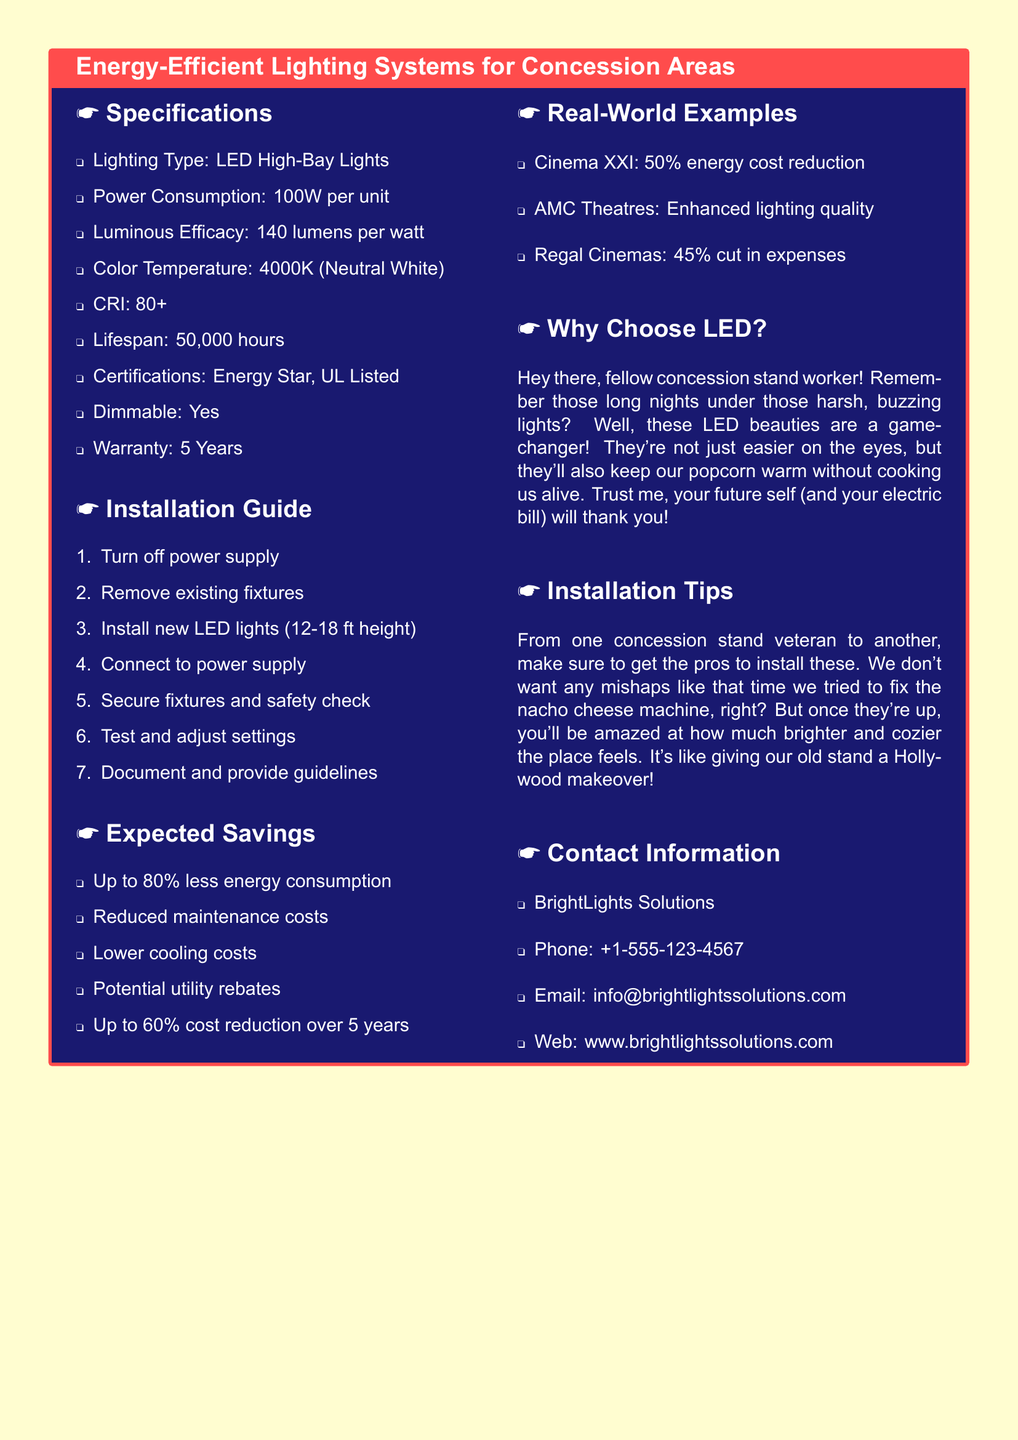What is the power consumption per unit? The power consumption is specifically stated in the specifications section of the document as 100W per unit.
Answer: 100W What type of lighting is used? The document specifies that LED High-Bay Lights are used in the concession areas.
Answer: LED High-Bay Lights What is the lifespan of the lighting system? The lifespan is indicated under specifications and is listed as 50,000 hours.
Answer: 50,000 hours What is the expected percentage of energy consumption reduction? The expected savings section states up to 80% less energy consumption.
Answer: 80% How long is the warranty for the lighting system? The warranty duration is mentioned in the specifications as 5 years.
Answer: 5 years What is one benefit of using LED lighting noted in the document? The document highlights reduced maintenance costs as a benefit of using LED lighting systems.
Answer: Reduced maintenance costs How many steps are there in the installation guide? The installation guide is enumerated with 7 specific steps, which can be counted directly from the document.
Answer: 7 Which certification is mentioned for the lighting? The specifications list Energy Star as one of the certifications for the lighting system.
Answer: Energy Star What example is given for energy cost reduction? The document mentions Cinema XXI as an example with a 50% energy cost reduction.
Answer: Cinema XXI 